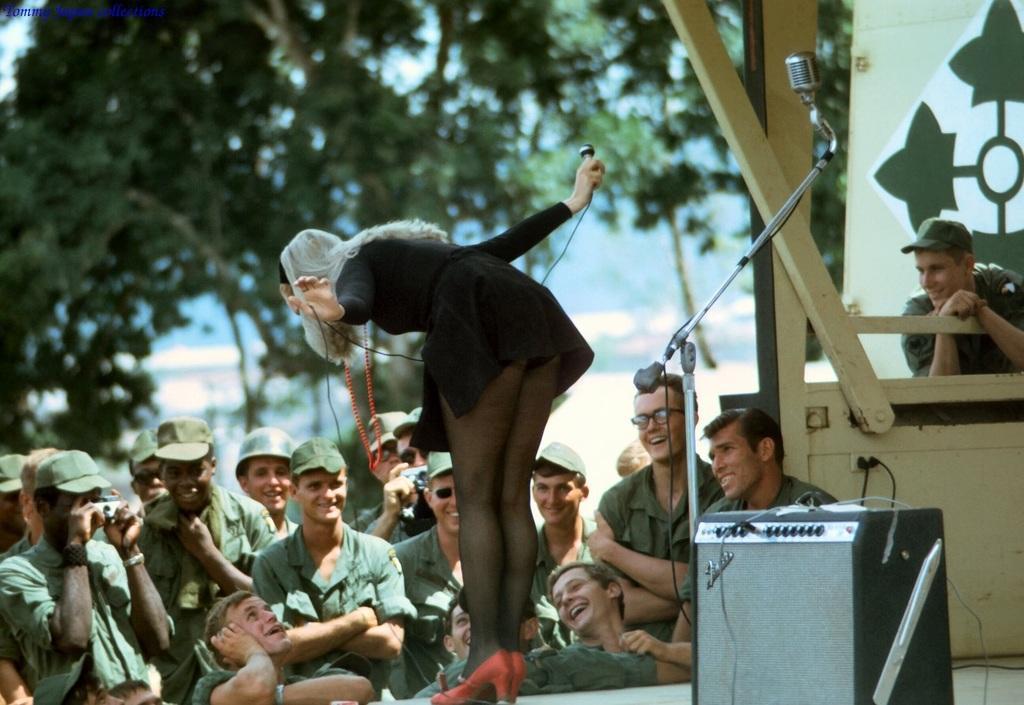In one or two sentences, can you explain what this image depicts? In this picture we can see group of people, In the middle of the image we can see a woman, she is holding a microphone, behind her we can find a speaker and another microphone, in the background we can see a hoarding and few trees. 